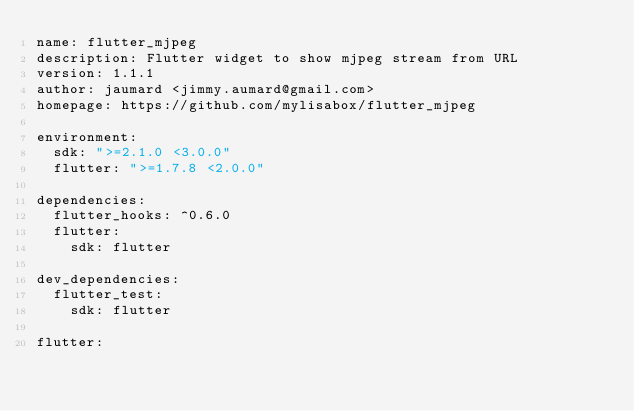<code> <loc_0><loc_0><loc_500><loc_500><_YAML_>name: flutter_mjpeg
description: Flutter widget to show mjpeg stream from URL
version: 1.1.1
author: jaumard <jimmy.aumard@gmail.com>
homepage: https://github.com/mylisabox/flutter_mjpeg

environment:
  sdk: ">=2.1.0 <3.0.0"
  flutter: ">=1.7.8 <2.0.0"

dependencies:
  flutter_hooks: ^0.6.0
  flutter:
    sdk: flutter

dev_dependencies:
  flutter_test:
    sdk: flutter

flutter:
</code> 